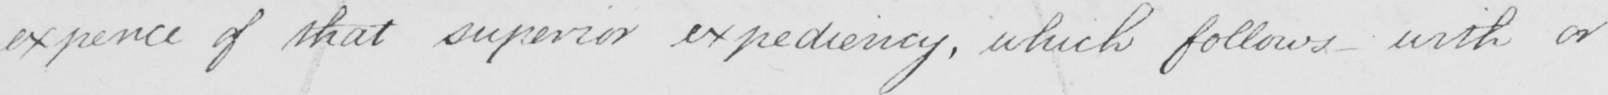Please transcribe the handwritten text in this image. expence of that superior expediency , which follows with or 